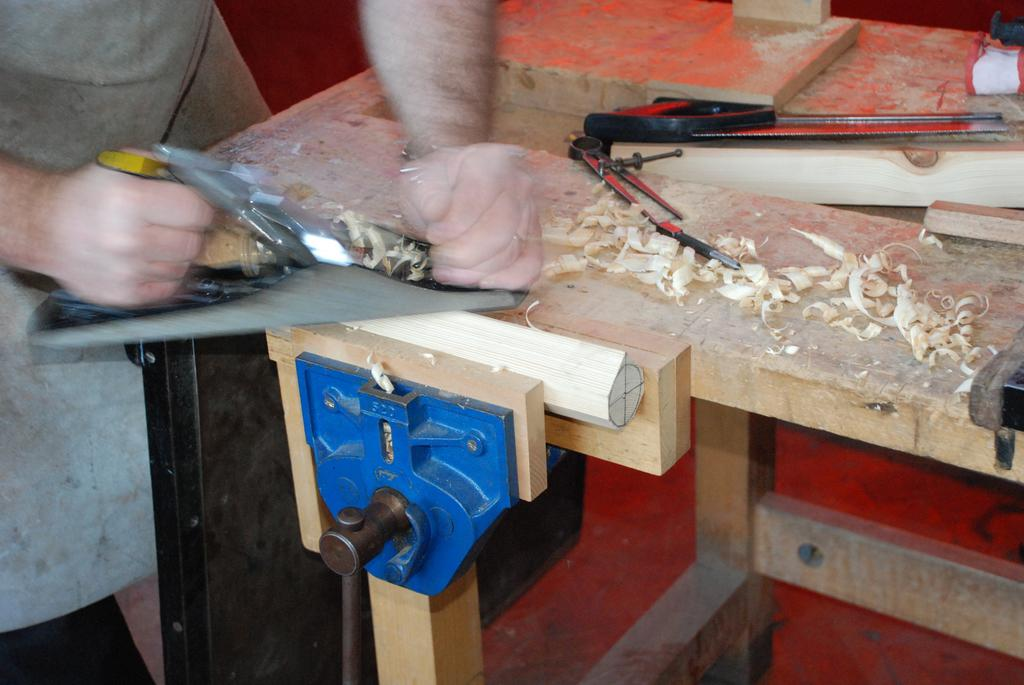What is the man in the image doing? The man is standing in the image and holding a saw. What is the man holding in the image? The man is holding a saw. What is located at the bottom of the image? There is wood at the bottom of the image. What is present on the table in the image? There is a table in the image, and a saw and a blade are placed on the table. Can you see any twigs floating down the river in the image? There is no river or twigs present in the image. Is the man in the image being attacked by any creatures? There are no creatures or attacks depicted in the image. 